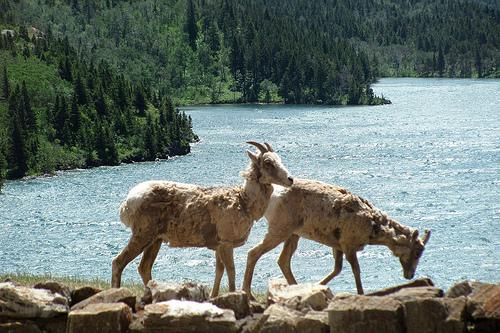Count the number of goats in the image and mention their unique features, if any. There are two goats, each having two horns, a shedding wool, and one goat has white and dark brown spots. Examine the image closely and describe the appearance and texture of both the goats. One goat has white and dark brown spots, partially shedding wool, and two horns; the other goat is also shedding wool and has two horns. What elements are present in this image's background? There are lush green trees covering the mountains, a calm body of water reflecting the blue sky, and brown rocks near the shore. What color are the trees in the background, and how would you describe their appearance? The trees are lush and green, creating a dense foliage cover over the mountains. Provide a simple and concise description of the image in one sentence. The image features two goats on rocks by a calm blue river with a backdrop of green mountains and trees. Describe the state of the water in the image and mention its colors. The water is calm, reflecting the blue sky, and has a shimmering patch in some areas. Identify the main action taking place in the image and mention the primary object involved in it. The main action is two goats standing on rocks, while one of them sniffs the rocks. In the given image, what are the animals' interactions with their surroundings? The goats are standing on brown rocks and sniffing them, while being close to the blue river and green trees. What sentiment does the image evoke by capturing the serene landscape? The image evokes a feeling of tranquility and connection with nature, showcasing the peaceful interaction between the goats and their surroundings. From the image, estimate how many trees are visible and describe their overall appearance. Several trees are visible, creating a dense coverage of lush green foliage over the mountains. "Can you spot a small red flower near the green grass?" No, it's not mentioned in the image. "Is the goat with three horns on the left side of the image?" There are no goats with three horns in the image, and all the captions mention either two horns or a single horn. "Is there a waterfall in the background behind the rocks?" There are no mentions of a waterfall or any similar features in the image. The only water-related captions are about the river, its calmness, and its blue color. "Can you find the bright pink tree in the bottom right corner?" There are no mentions of any colored trees other than green or leafy green. Therefore, there are no bright pink trees in the image. "Are there any birds sitting on the rocks near the goats?" None of the captions mention birds or any animals other than goats in the image. Therefore, there are no birds in the scene. 